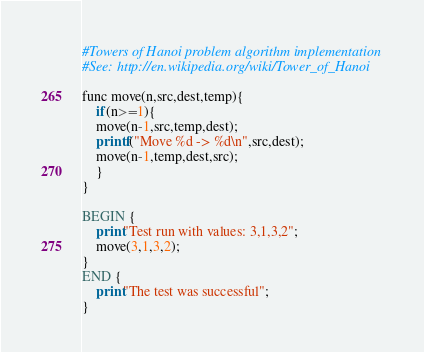Convert code to text. <code><loc_0><loc_0><loc_500><loc_500><_Awk_>#Towers of Hanoi problem algorithm implementation
#See: http://en.wikipedia.org/wiki/Tower_of_Hanoi

func move(n,src,dest,temp){
 	if(n>=1){
    move(n-1,src,temp,dest);
    printf("Move %d -> %d\n",src,dest);
    move(n-1,temp,dest,src);
	}
}

BEGIN {
	print"Test run with values: 3,1,3,2";
	move(3,1,3,2);
}
END {
	print"The test was successful";
}</code> 